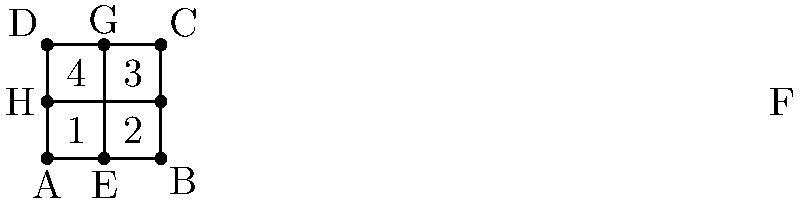At Victoria Rosport's home stadium, the seating sections are arranged as shown in the diagram. If the stadium is perfectly square and the diagonal lines represent aisles, which pairs of angles are congruent? To determine which pairs of angles are congruent, let's analyze the diagram step-by-step:

1. The stadium is described as perfectly square, which means all sides are equal and all angles are 90°.

2. The diagonal lines (aisles) divide the square into four congruent triangles. This is because:
   a) The diagonals of a square bisect each other.
   b) The diagonals of a square are equal in length.
   c) The diagonals of a square intersect at right angles (90°).

3. In a square, opposite angles formed by the diagonals are always congruent. This means:
   - Angle 1 ≅ Angle 3
   - Angle 2 ≅ Angle 4

4. Additionally, all four angles (1, 2, 3, and 4) are actually congruent to each other. This is because:
   a) The diagonals divide the 90° angles of the square into two equal parts.
   b) 90° ÷ 2 = 45°
   c) Therefore, all four angles are 45°.

5. So, we can conclude that:
   Angle 1 ≅ Angle 2 ≅ Angle 3 ≅ Angle 4

Thus, all pairs of angles in the seating layout are congruent to each other.
Answer: All pairs: 1≅2≅3≅4 